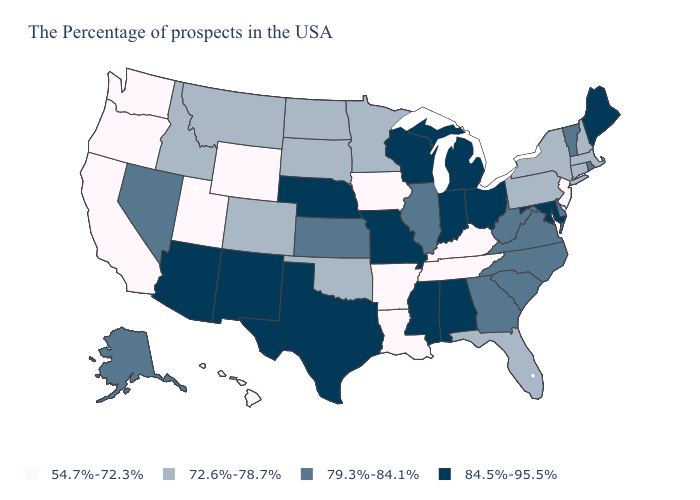Name the states that have a value in the range 72.6%-78.7%?
Short answer required. Massachusetts, New Hampshire, Connecticut, New York, Pennsylvania, Florida, Minnesota, Oklahoma, South Dakota, North Dakota, Colorado, Montana, Idaho. Does Michigan have the highest value in the USA?
Be succinct. Yes. Which states have the lowest value in the USA?
Keep it brief. New Jersey, Kentucky, Tennessee, Louisiana, Arkansas, Iowa, Wyoming, Utah, California, Washington, Oregon, Hawaii. Among the states that border Ohio , which have the lowest value?
Concise answer only. Kentucky. Which states have the lowest value in the South?
Answer briefly. Kentucky, Tennessee, Louisiana, Arkansas. Does Louisiana have the same value as New Mexico?
Keep it brief. No. Does Arizona have the highest value in the West?
Give a very brief answer. Yes. Among the states that border Indiana , does Michigan have the lowest value?
Write a very short answer. No. Does Iowa have the lowest value in the USA?
Short answer required. Yes. What is the lowest value in the USA?
Short answer required. 54.7%-72.3%. Name the states that have a value in the range 54.7%-72.3%?
Write a very short answer. New Jersey, Kentucky, Tennessee, Louisiana, Arkansas, Iowa, Wyoming, Utah, California, Washington, Oregon, Hawaii. Name the states that have a value in the range 84.5%-95.5%?
Keep it brief. Maine, Maryland, Ohio, Michigan, Indiana, Alabama, Wisconsin, Mississippi, Missouri, Nebraska, Texas, New Mexico, Arizona. Does New Mexico have the highest value in the USA?
Write a very short answer. Yes. Among the states that border Iowa , does Illinois have the highest value?
Answer briefly. No. What is the value of Arkansas?
Quick response, please. 54.7%-72.3%. 